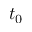Convert formula to latex. <formula><loc_0><loc_0><loc_500><loc_500>t _ { 0 }</formula> 